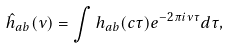<formula> <loc_0><loc_0><loc_500><loc_500>\hat { h } _ { a b } ( \nu ) = \int h _ { a b } ( c \tau ) e ^ { - 2 \pi i \nu \tau } d \tau ,</formula> 